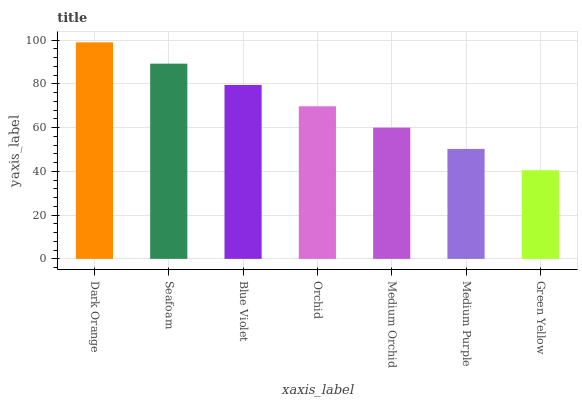Is Seafoam the minimum?
Answer yes or no. No. Is Seafoam the maximum?
Answer yes or no. No. Is Dark Orange greater than Seafoam?
Answer yes or no. Yes. Is Seafoam less than Dark Orange?
Answer yes or no. Yes. Is Seafoam greater than Dark Orange?
Answer yes or no. No. Is Dark Orange less than Seafoam?
Answer yes or no. No. Is Orchid the high median?
Answer yes or no. Yes. Is Orchid the low median?
Answer yes or no. Yes. Is Dark Orange the high median?
Answer yes or no. No. Is Green Yellow the low median?
Answer yes or no. No. 